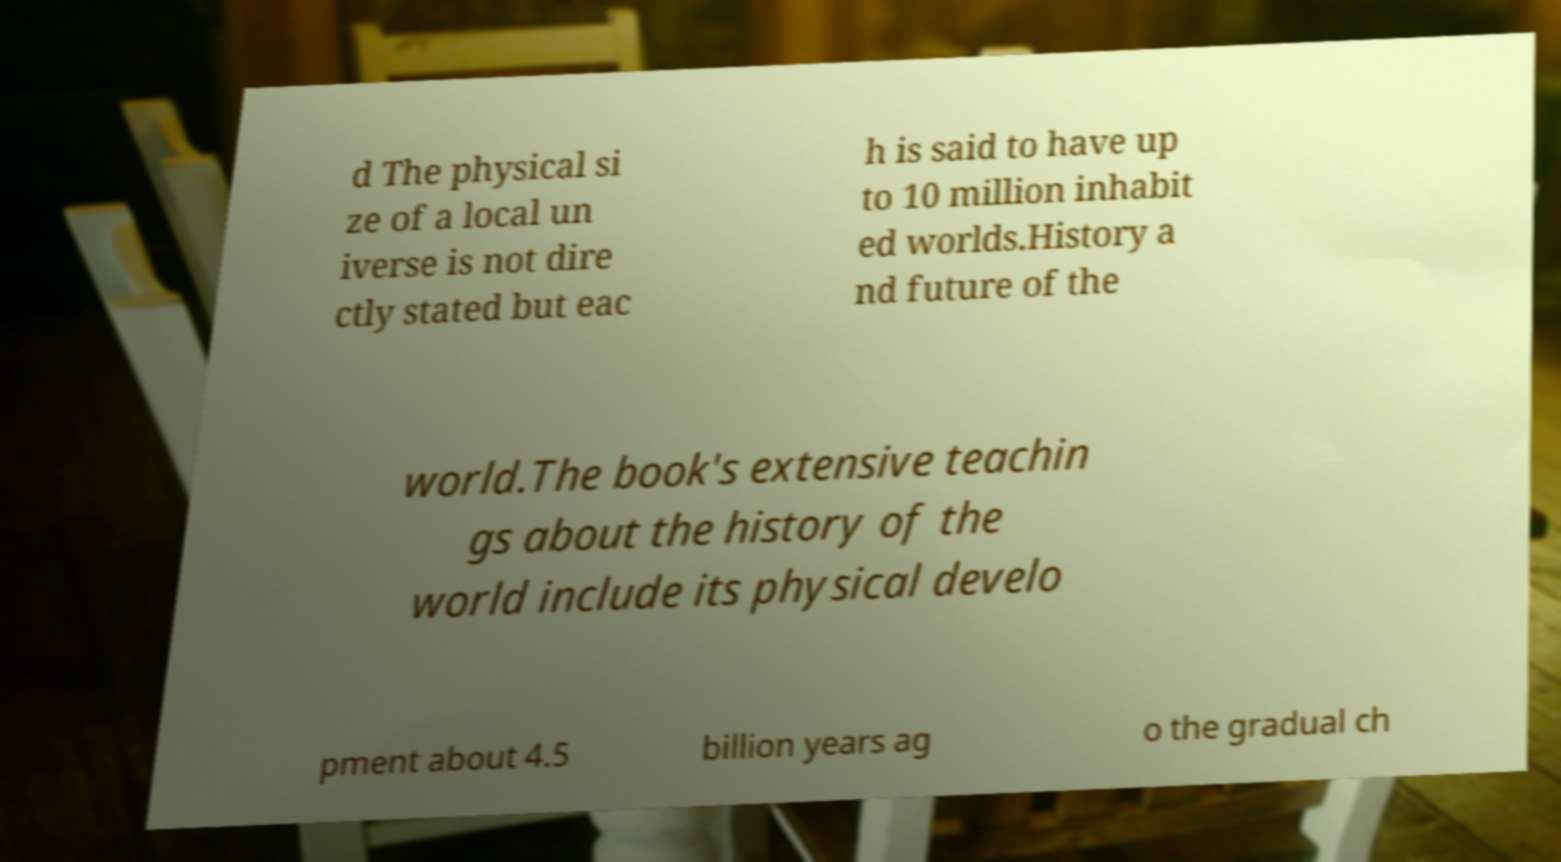There's text embedded in this image that I need extracted. Can you transcribe it verbatim? d The physical si ze of a local un iverse is not dire ctly stated but eac h is said to have up to 10 million inhabit ed worlds.History a nd future of the world.The book's extensive teachin gs about the history of the world include its physical develo pment about 4.5 billion years ag o the gradual ch 